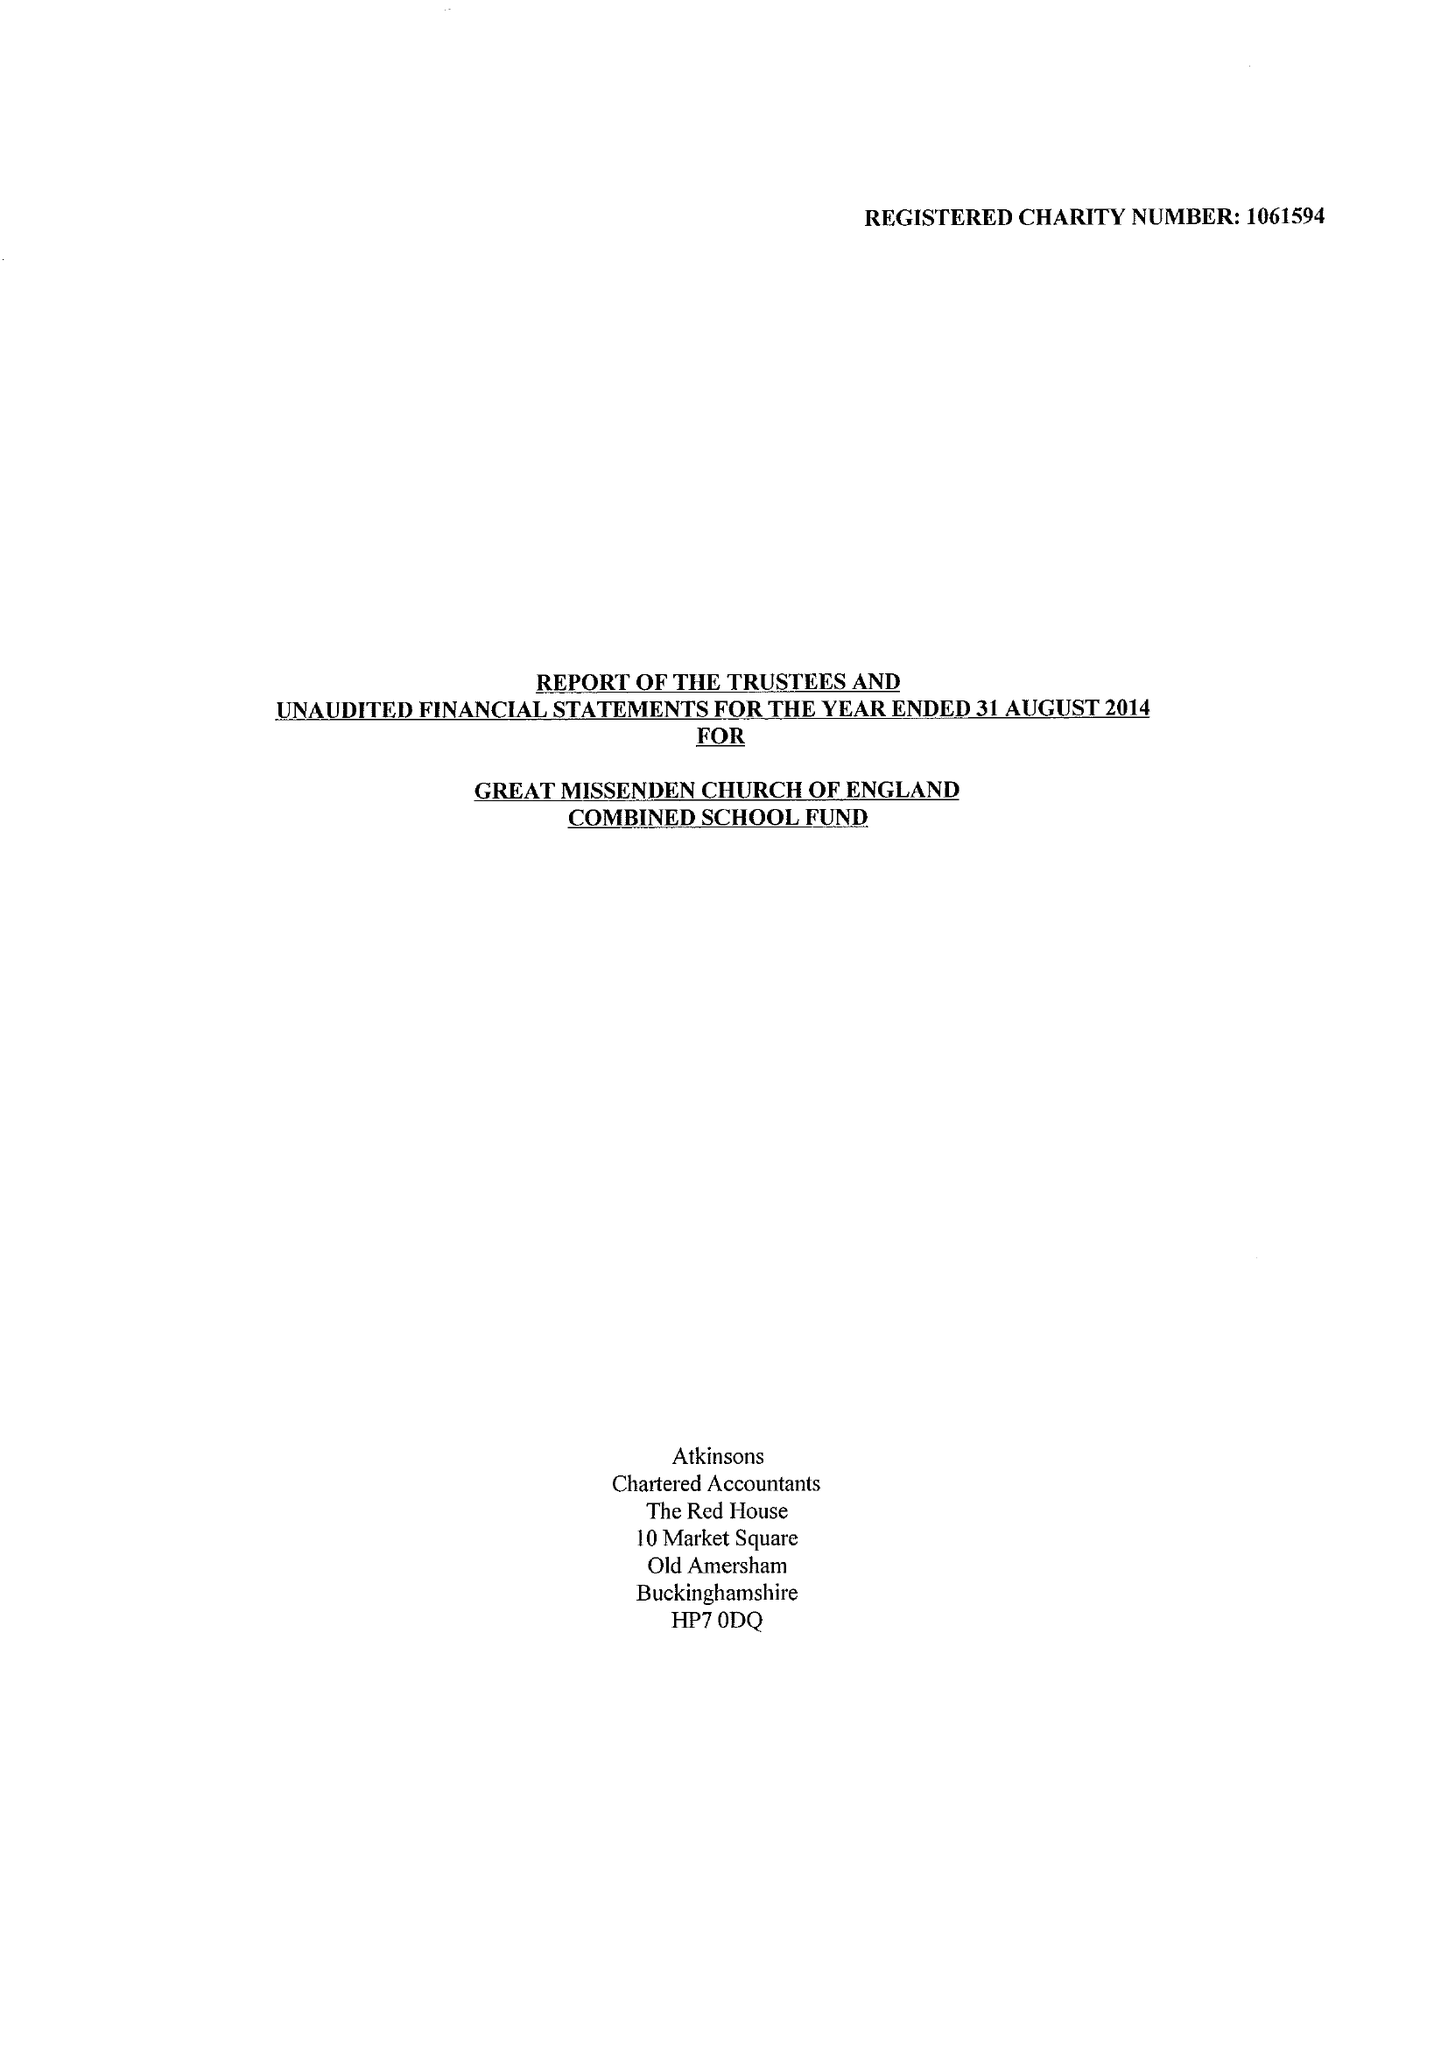What is the value for the address__postcode?
Answer the question using a single word or phrase. HP16 0AZ 